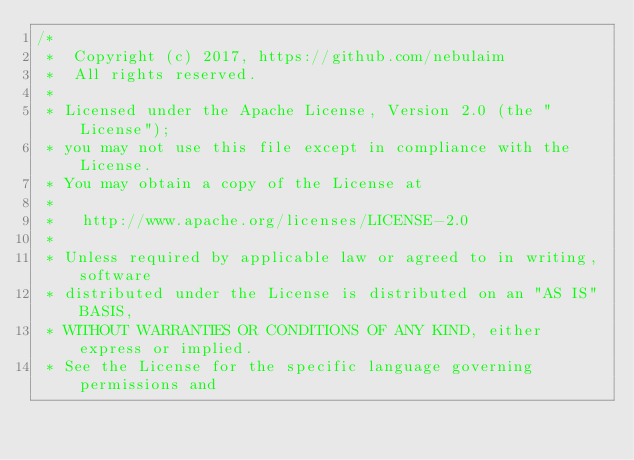<code> <loc_0><loc_0><loc_500><loc_500><_Go_>/*
 *  Copyright (c) 2017, https://github.com/nebulaim
 *  All rights reserved.
 *
 * Licensed under the Apache License, Version 2.0 (the "License");
 * you may not use this file except in compliance with the License.
 * You may obtain a copy of the License at
 *
 *   http://www.apache.org/licenses/LICENSE-2.0
 *
 * Unless required by applicable law or agreed to in writing, software
 * distributed under the License is distributed on an "AS IS" BASIS,
 * WITHOUT WARRANTIES OR CONDITIONS OF ANY KIND, either express or implied.
 * See the License for the specific language governing permissions and</code> 